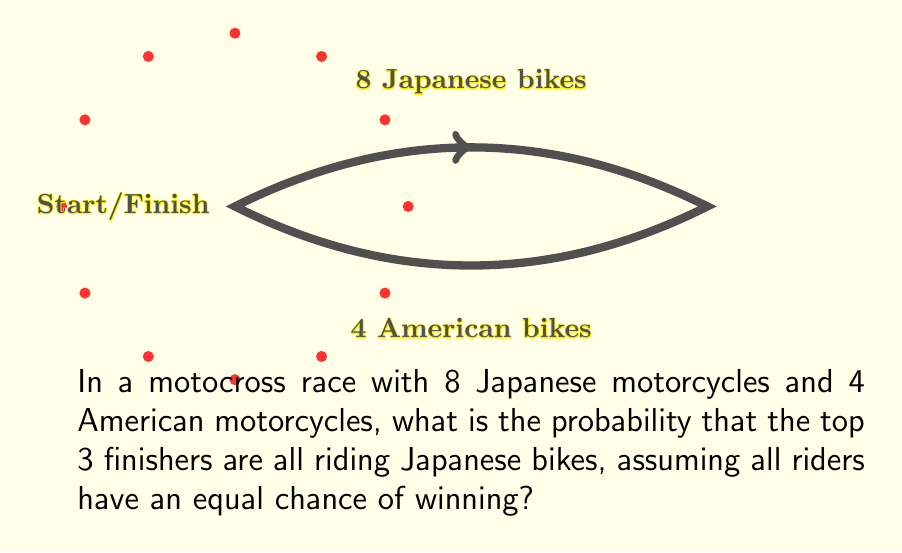Can you solve this math problem? To solve this problem, we'll use the concept of combinatorics and probability.

Step 1: Calculate the total number of ways to select the top 3 finishers from 12 motorcycles.
Total combinations = $\binom{12}{3} = \frac{12!}{3!(12-3)!} = \frac{12!}{3!9!} = 220$

Step 2: Calculate the number of ways to select 3 Japanese motorcycles from 8.
Favorable combinations = $\binom{8}{3} = \frac{8!}{3!(8-3)!} = \frac{8!}{3!5!} = 56$

Step 3: Calculate the probability by dividing favorable outcomes by total outcomes.
Probability = $\frac{\text{Favorable combinations}}{\text{Total combinations}} = \frac{56}{220} = \frac{14}{55}$

Step 4: Simplify the fraction (if possible).
$\frac{14}{55}$ is already in its simplest form.

Therefore, the probability that the top 3 finishers are all riding Japanese bikes is $\frac{14}{55}$ or approximately 0.2545 (25.45%).
Answer: $\frac{14}{55}$ 